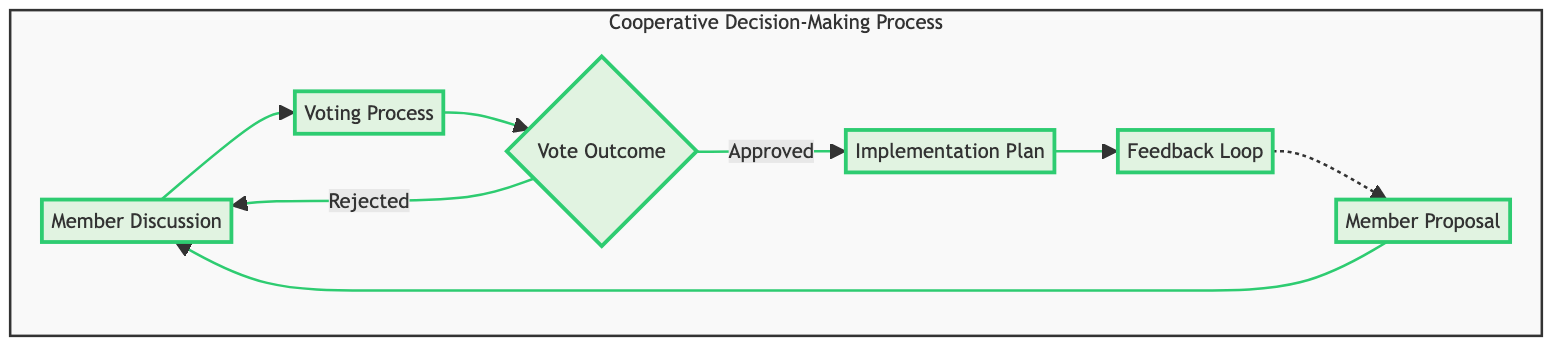What is the first step in the collaborative decision-making process? The first step, indicated in the diagram, is "Member Proposal," where an idea is presented by a cooperative member.
Answer: Member Proposal How many nodes are present in the collaborative decision-making process? By counting the elements in the diagram, there are a total of six nodes: Member Proposal, Member Discussion, Voting Process, Vote Outcome, Implementation Plan, and Feedback Loop.
Answer: Six What follows the "Voting Process" in the flow chart? After the "Voting Process," the next node is "Vote Outcome," which determines if the proposal was accepted or rejected.
Answer: Vote Outcome What happens if the vote outcome is "Rejected"? If the vote outcome is "Rejected," the flowchart indicates it leads back to "Member Discussion" for further conversation.
Answer: Member Discussion Which node indicates a response mechanism regarding satisfaction? The "Feedback Loop" node represents the process of collecting responses from members about their satisfaction with the implementation of the proposal.
Answer: Feedback Loop What is the relationship between "Vote Outcome" and "Implementation Plan"? If the "Vote Outcome" is approved, the process directly leads to the "Implementation Plan," where the approved proposal is detailed for execution.
Answer: Approved What is the last step in the flow of this decision-making process? The last step is the "Feedback Loop," which is the point where member responses are gathered regarding the implementation.
Answer: Feedback Loop How many edges connect the "Vote Outcome" node to other nodes? The "Vote Outcome" node in the diagram connects to two edges: one leading to "Implementation Plan" and another one leading back to "Member Discussion" if the proposal is rejected.
Answer: Two What is a repeated action in the decision-making process? The action represented by the "Feedback Loop" indicates a cycle where members provide ongoing feedback about the proposal’s implementation, which connects back to "Member Proposal."
Answer: Feedback Loop 